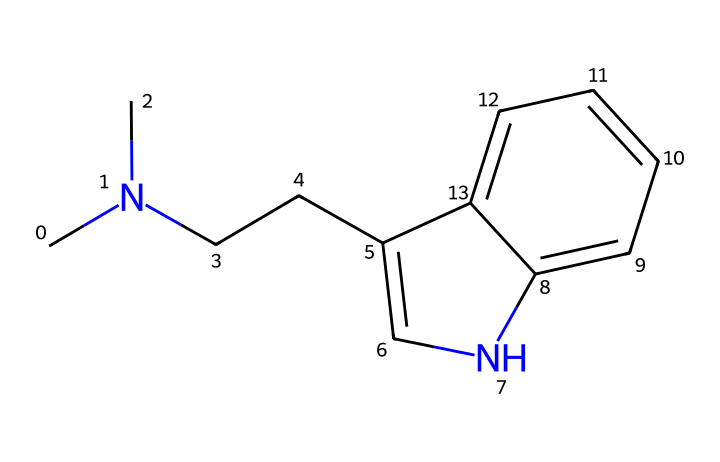What is the molecular formula of this chemical? To determine the molecular formula, we need to count the total number of carbon (C), hydrogen (H), and nitrogen (N) atoms present in the structure. The structure contains 12 carbon atoms, 16 hydrogen atoms, and 2 nitrogen atoms, so the molecular formula is C12H16N2.
Answer: C12H16N2 How many nitrogen atoms are in this compound? The SMILES representation shows two nitrogen atoms, which are represented by 'N' in the structure.
Answer: 2 What type of chemical compound is DMT classified as? DMT is classified as a tryptamine, which is a type of alkaloid derived from the indole structure and contains an amine group.
Answer: tryptamine Which functional group is associated with the hallucinogenic properties of DMT? The presence of the indole structure, which contains a nitrogen atom and contributes to the chemical's interaction with serotonin receptors, is crucial for its hallucinogenic effects.
Answer: indole What is the total number of rings in the structure? Analyzing the SMILES representation, there are two interconnected rings in the structure, indicating a bicyclic structure characteristic of many alkaloids like DMT.
Answer: 2 Is this compound a solid, liquid, or gas at room temperature? Based on its properties, DMT is typically a solid or a viscous liquid at room temperature, depending on its purity and preparation form.
Answer: solid 